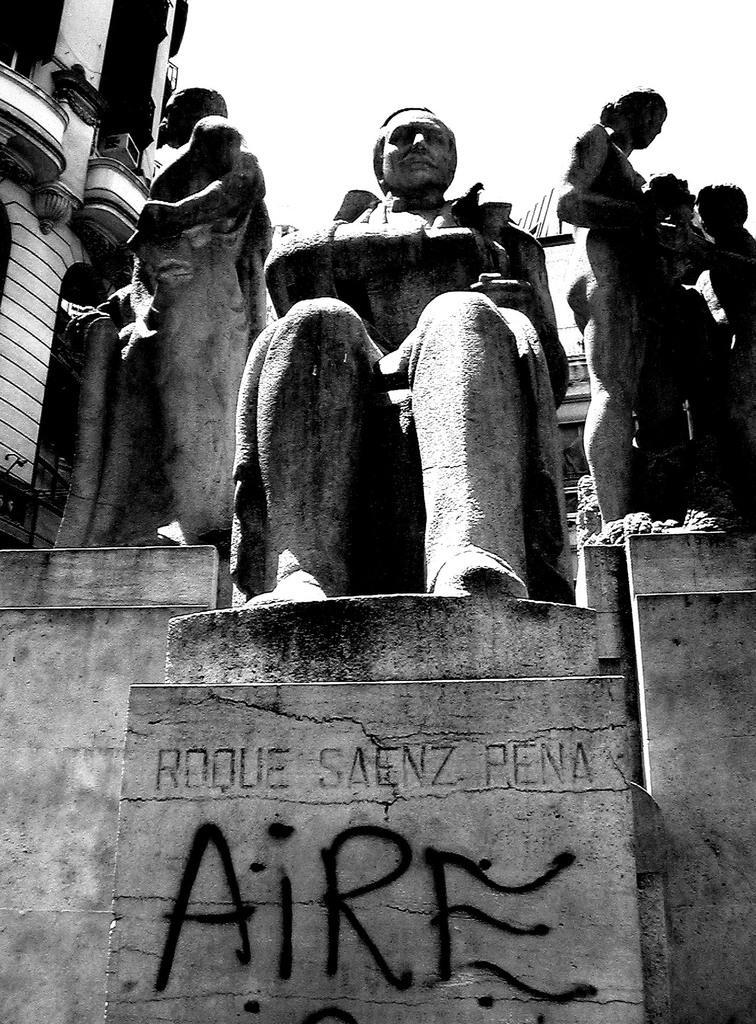Please provide a concise description of this image. This image consists of sculptures. At the bottom, there is a text on the wall. On the left, we can see a building. At the top, there is sky. 